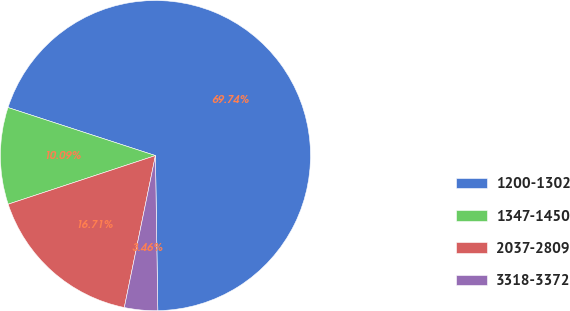<chart> <loc_0><loc_0><loc_500><loc_500><pie_chart><fcel>1200-1302<fcel>1347-1450<fcel>2037-2809<fcel>3318-3372<nl><fcel>69.74%<fcel>10.09%<fcel>16.71%<fcel>3.46%<nl></chart> 